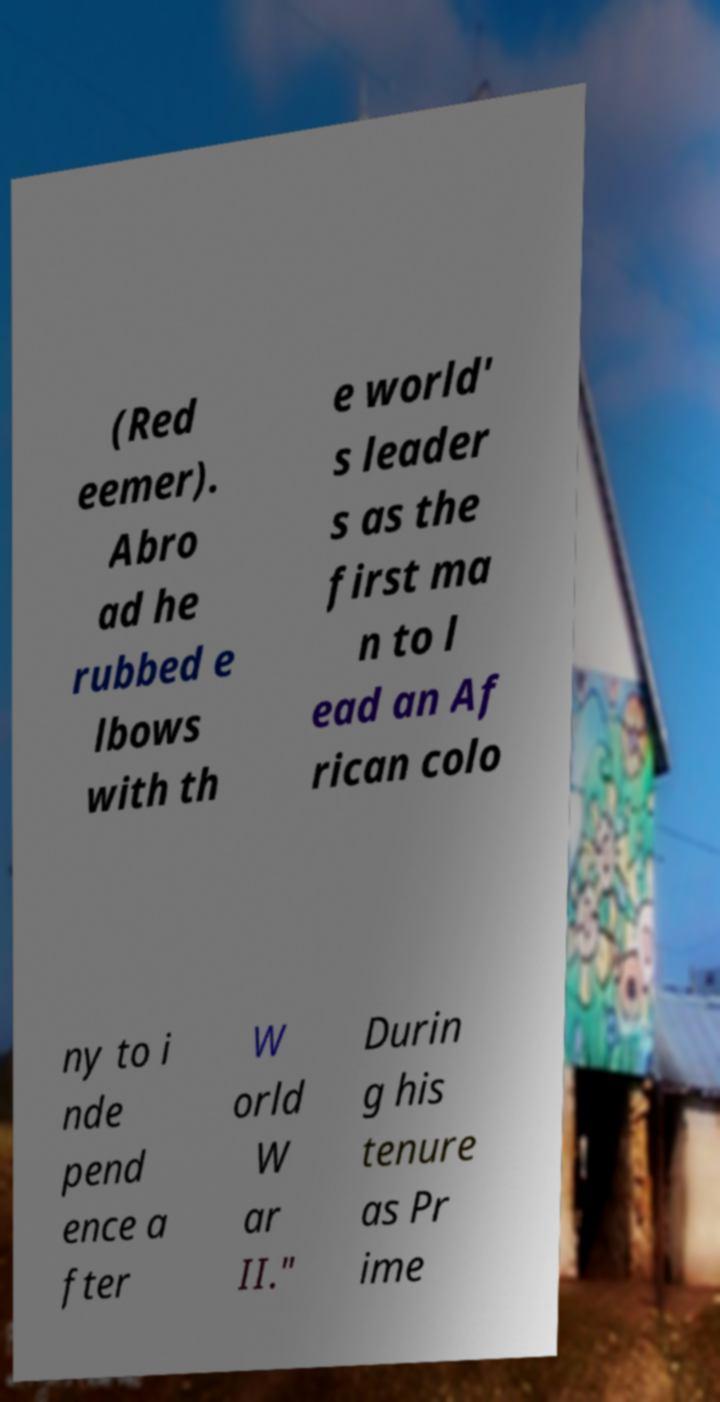Could you extract and type out the text from this image? (Red eemer). Abro ad he rubbed e lbows with th e world' s leader s as the first ma n to l ead an Af rican colo ny to i nde pend ence a fter W orld W ar II." Durin g his tenure as Pr ime 